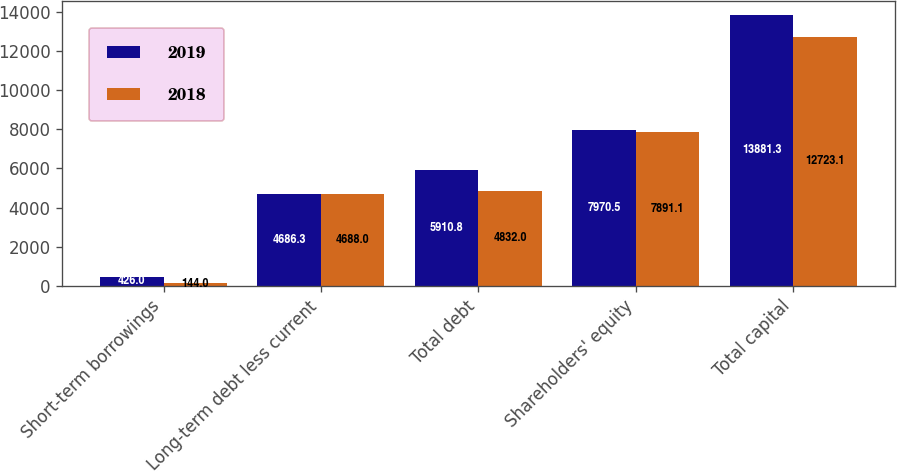Convert chart. <chart><loc_0><loc_0><loc_500><loc_500><stacked_bar_chart><ecel><fcel>Short-term borrowings<fcel>Long-term debt less current<fcel>Total debt<fcel>Shareholders' equity<fcel>Total capital<nl><fcel>2019<fcel>426<fcel>4686.3<fcel>5910.8<fcel>7970.5<fcel>13881.3<nl><fcel>2018<fcel>144<fcel>4688<fcel>4832<fcel>7891.1<fcel>12723.1<nl></chart> 